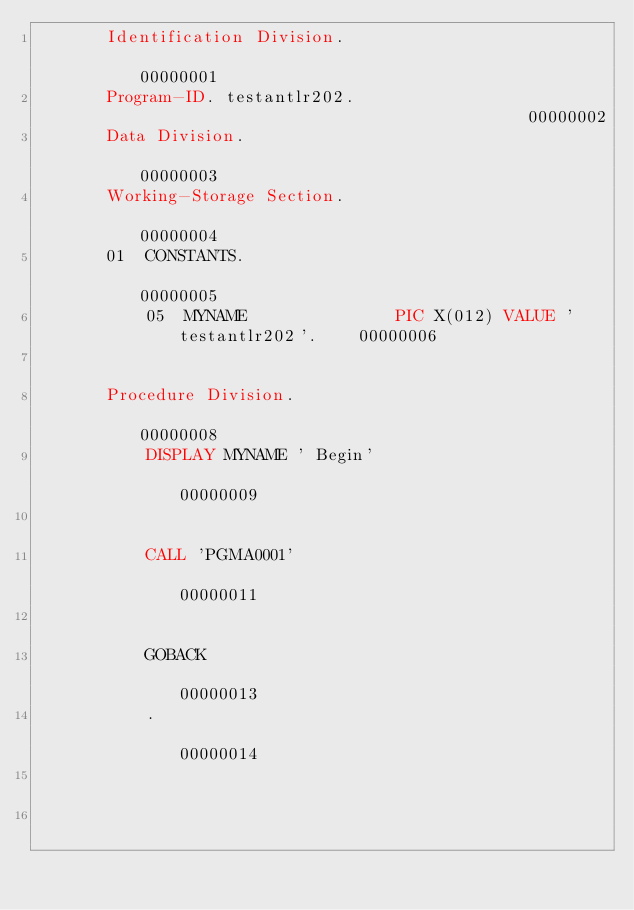<code> <loc_0><loc_0><loc_500><loc_500><_COBOL_>       Identification Division.                                         00000001
       Program-ID. testantlr202.                                        00000002
       Data Division.                                                   00000003
       Working-Storage Section.                                         00000004
       01  CONSTANTS.                                                   00000005
           05  MYNAME               PIC X(012) VALUE 'testantlr202'.    00000006
                                                                        00000007
       Procedure Division.                                              00000008
           DISPLAY MYNAME ' Begin'                                      00000009
                                                                        00000010
           CALL 'PGMA0001'                                              00000011
                                                                        00000012
           GOBACK                                                       00000013
           .                                                            00000014
                                                                        00000015
                                                                        00000016
</code> 